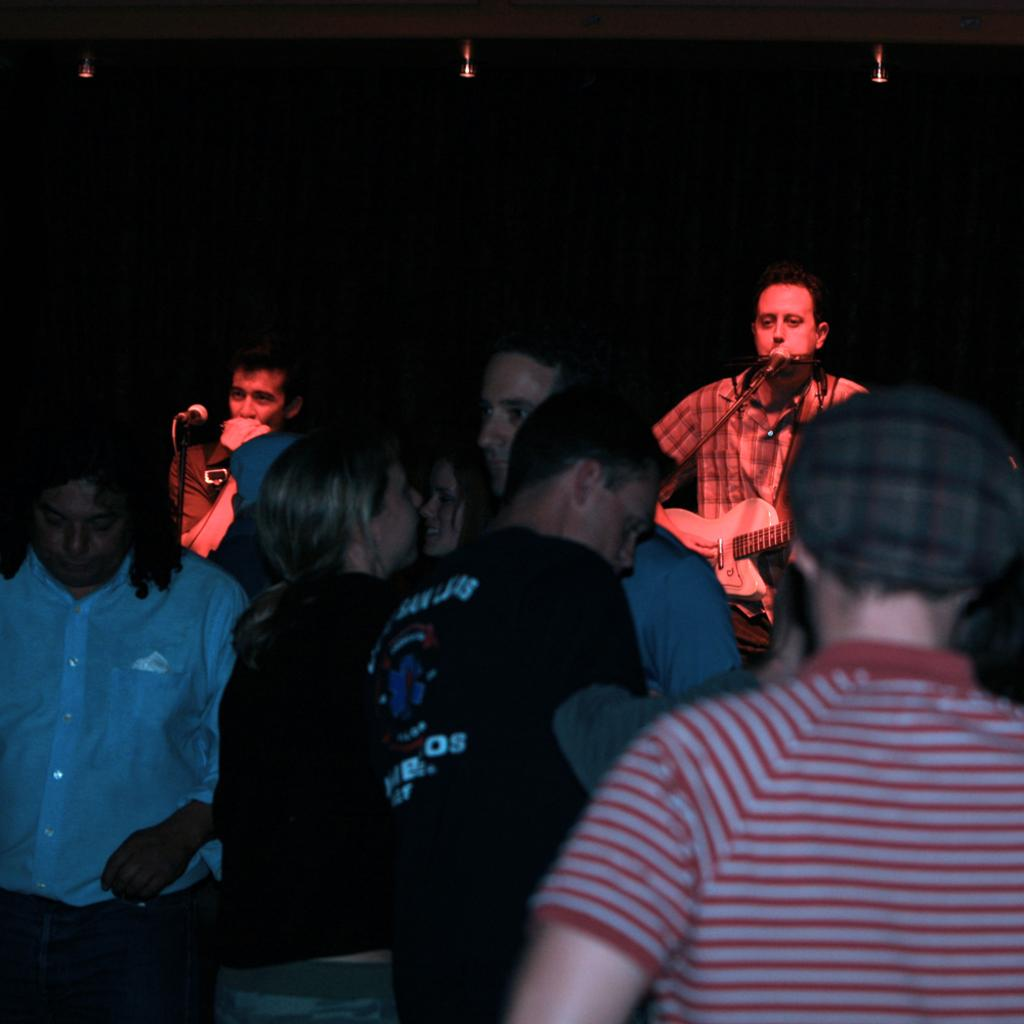What is happening in the image involving a group of people? There is a crowd in the image. What is the man in the image doing? The man is singing in the image. How is the man amplifying his voice while singing? The man is using a microphone while singing. What musical instrument is the man playing in the image? The man is playing a guitar in the image. What color is the bubble that the man is blowing while playing the guitar in the image? There is no bubble present in the image; the man is playing a guitar and singing with a microphone. 